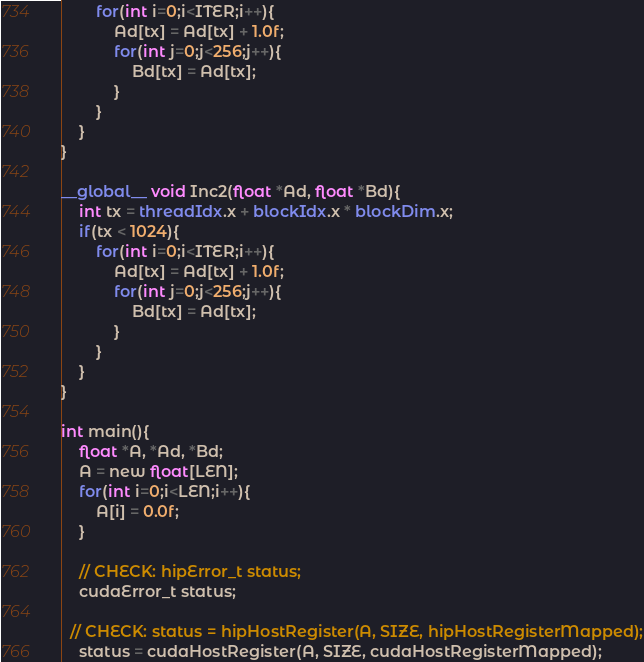<code> <loc_0><loc_0><loc_500><loc_500><_Cuda_>		for(int i=0;i<ITER;i++){
			Ad[tx] = Ad[tx] + 1.0f;
			for(int j=0;j<256;j++){
				Bd[tx] = Ad[tx];
			}
		}
	}
}

__global__ void Inc2(float *Ad, float *Bd){
	int tx = threadIdx.x + blockIdx.x * blockDim.x;
	if(tx < 1024){
		for(int i=0;i<ITER;i++){
			Ad[tx] = Ad[tx] + 1.0f;
			for(int j=0;j<256;j++){
				Bd[tx] = Ad[tx];
			}
		}
	}
}

int main(){
	float *A, *Ad, *Bd;
	A = new float[LEN];
	for(int i=0;i<LEN;i++){
		A[i] = 0.0f;
	}

	// CHECK: hipError_t status;
	cudaError_t status;

  // CHECK: status = hipHostRegister(A, SIZE, hipHostRegisterMapped);
	status = cudaHostRegister(A, SIZE, cudaHostRegisterMapped);</code> 